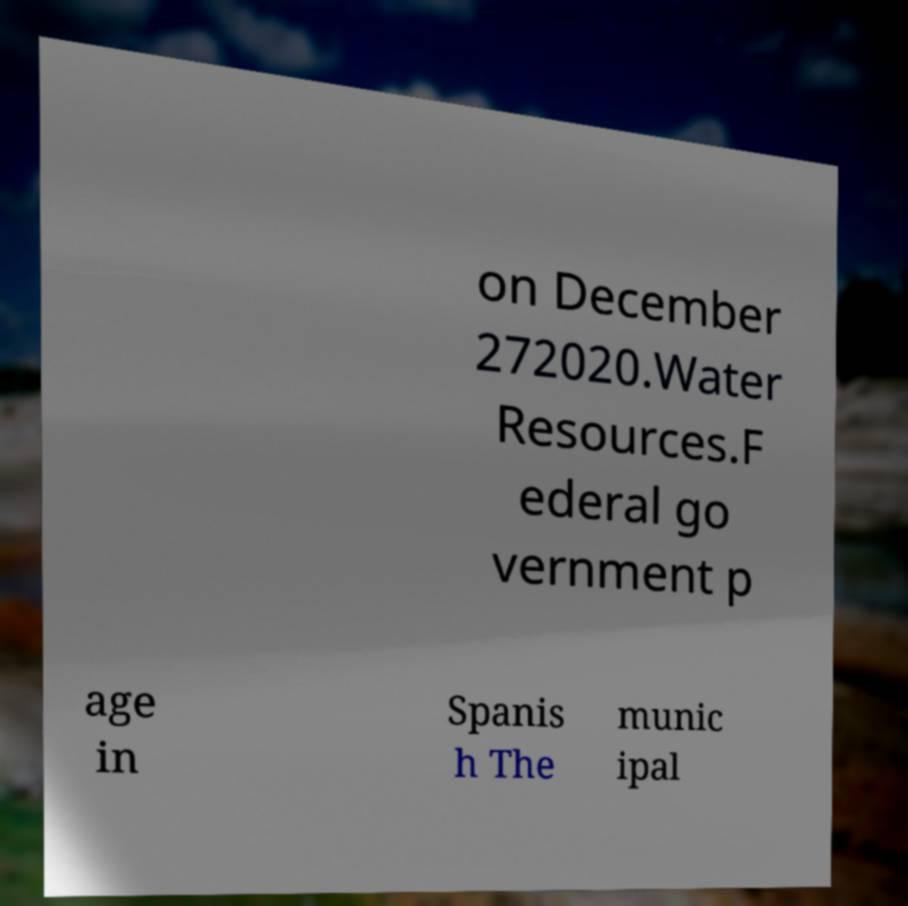There's text embedded in this image that I need extracted. Can you transcribe it verbatim? on December 272020.Water Resources.F ederal go vernment p age in Spanis h The munic ipal 